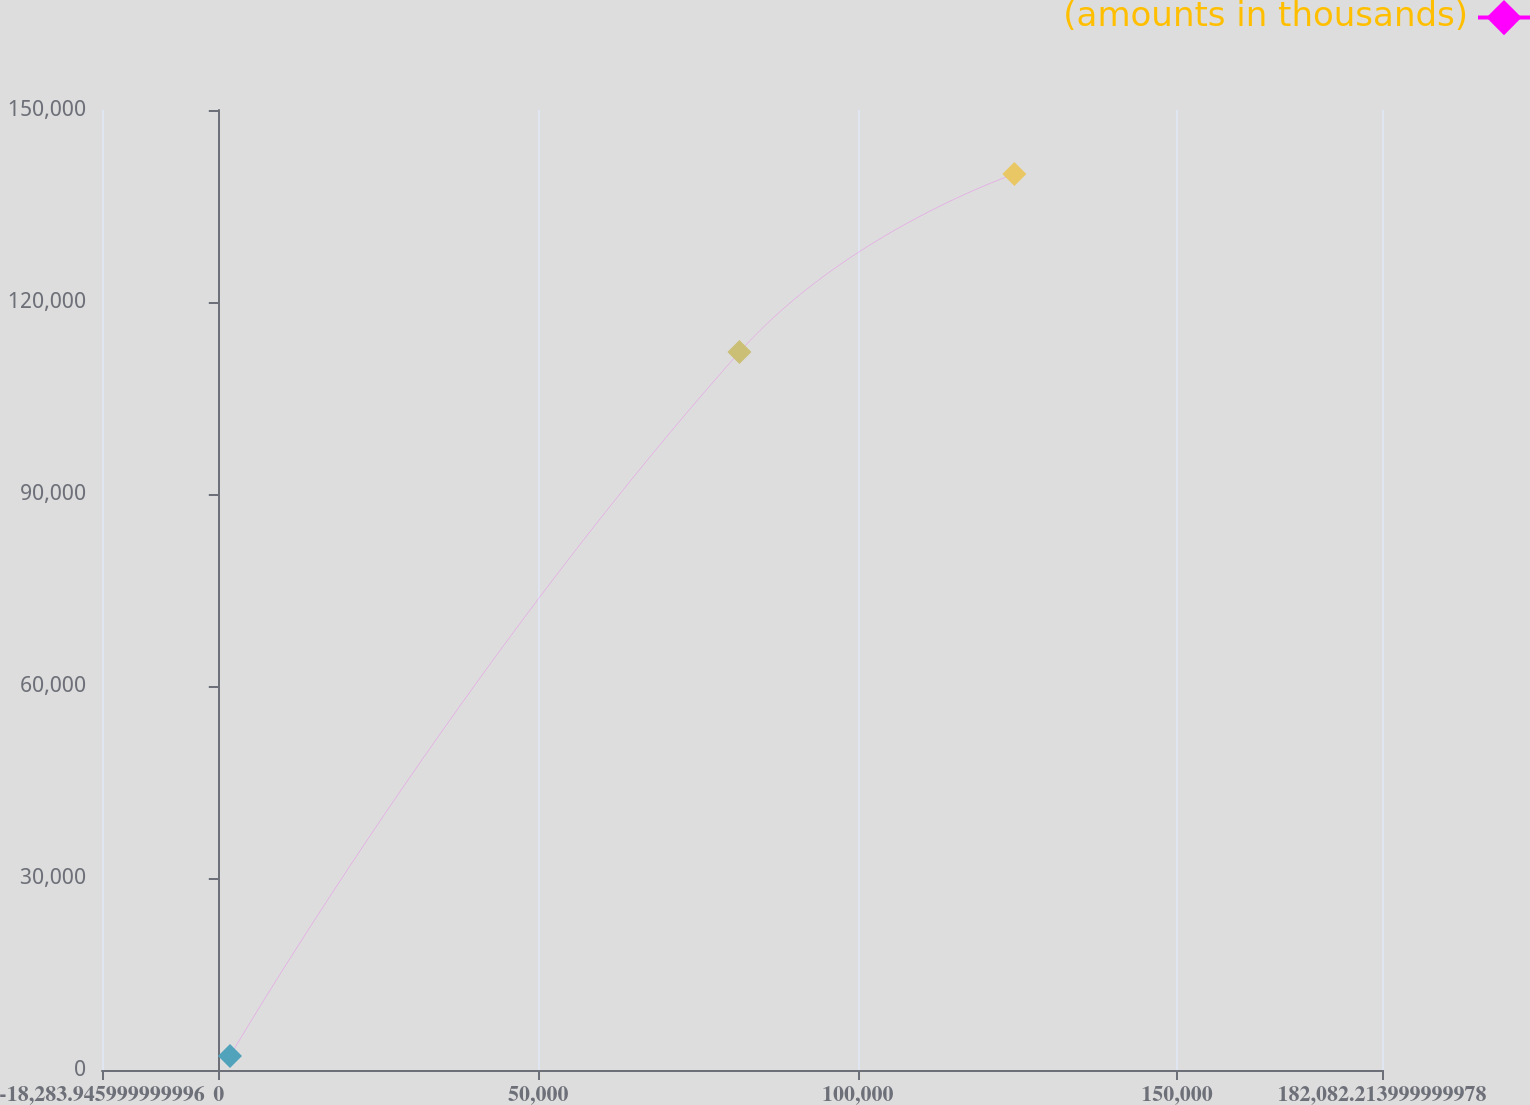<chart> <loc_0><loc_0><loc_500><loc_500><line_chart><ecel><fcel>(amounts in thousands)<nl><fcel>1752.67<fcel>2190.16<nl><fcel>81497.5<fcel>112176<nl><fcel>124536<fcel>139994<nl><fcel>202119<fcel>280371<nl></chart> 